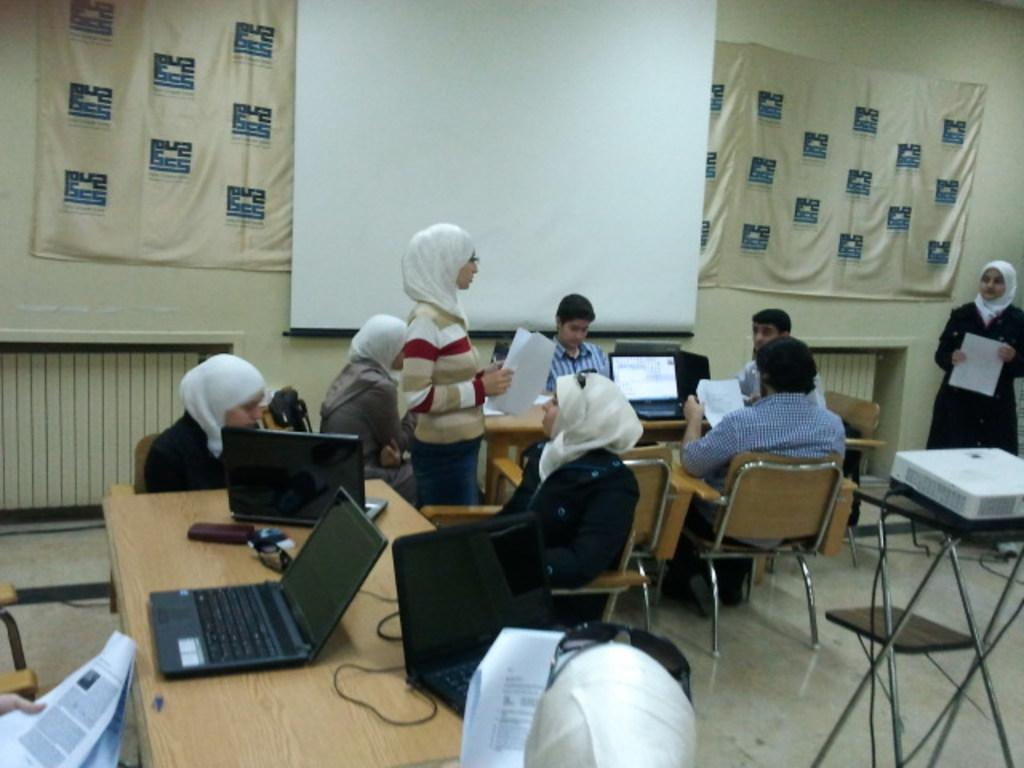How many people are in the image? There are multiple people in the image. What are some of the people doing in the image? Some people are sitting on chairs, while others are standing. What can be seen on the wall in the image? There is a whiteboard in the image. What objects are on the tables in the image? There are tables with laptops on them in the image. What type of milk is being served to the band in the image? There is no band or milk present in the image. What brand of toothpaste is visible on the whiteboard in the image? There is no toothpaste visible on the whiteboard or anywhere else in the image. 